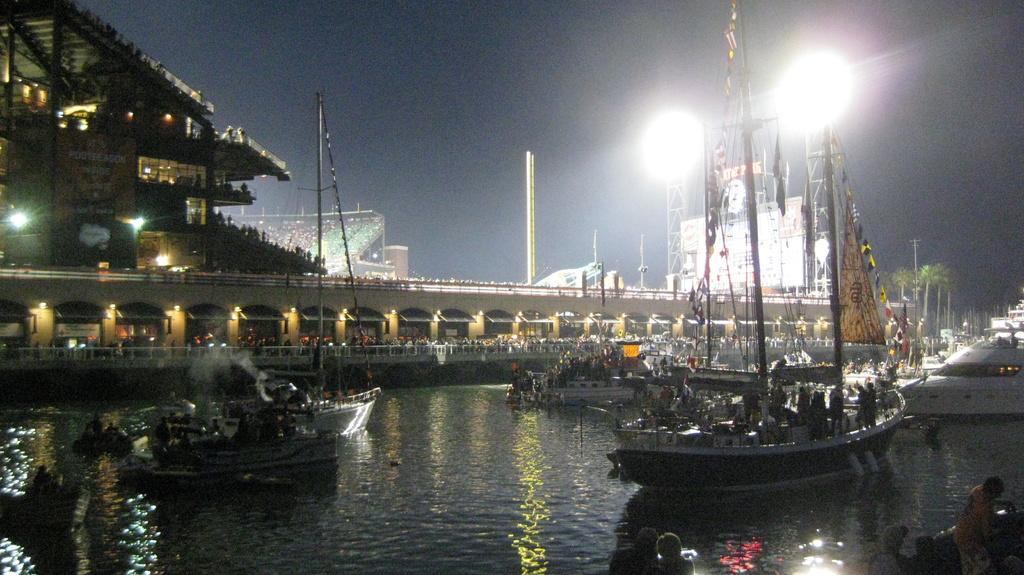Can you describe this image briefly? In this image I can see at the bottom, there is water and few boats are moving in this. In the middle it looks like a very big ship with lights. On the right side there are focus lights, at the top it is the sky. 